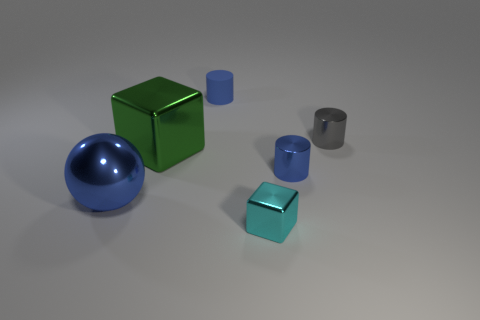What is the material of the cylinder that is in front of the gray cylinder?
Provide a succinct answer. Metal. What is the size of the cyan block that is made of the same material as the big green object?
Offer a very short reply. Small. There is a blue cylinder right of the small block; does it have the same size as the metallic sphere that is left of the small gray object?
Your answer should be compact. No. There is another blue cylinder that is the same size as the blue metal cylinder; what material is it?
Ensure brevity in your answer.  Rubber. The cylinder that is to the left of the gray metallic cylinder and in front of the blue matte thing is made of what material?
Offer a terse response. Metal. Are any big yellow rubber cubes visible?
Your response must be concise. No. There is a big metal sphere; does it have the same color as the small cylinder that is left of the cyan metal thing?
Your response must be concise. Yes. There is another tiny cylinder that is the same color as the small rubber cylinder; what is its material?
Ensure brevity in your answer.  Metal. Is there anything else that is the same shape as the big blue metal thing?
Ensure brevity in your answer.  No. The small metal thing in front of the blue metal object on the left side of the metallic block that is right of the small blue rubber thing is what shape?
Make the answer very short. Cube. 